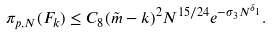<formula> <loc_0><loc_0><loc_500><loc_500>\pi _ { p , N } ( F _ { k } ) \leq C _ { 8 } ( \tilde { m } - k ) ^ { 2 } N ^ { 1 5 / 2 4 } e ^ { - \sigma _ { 3 } N ^ { \delta _ { 1 } } } .</formula> 